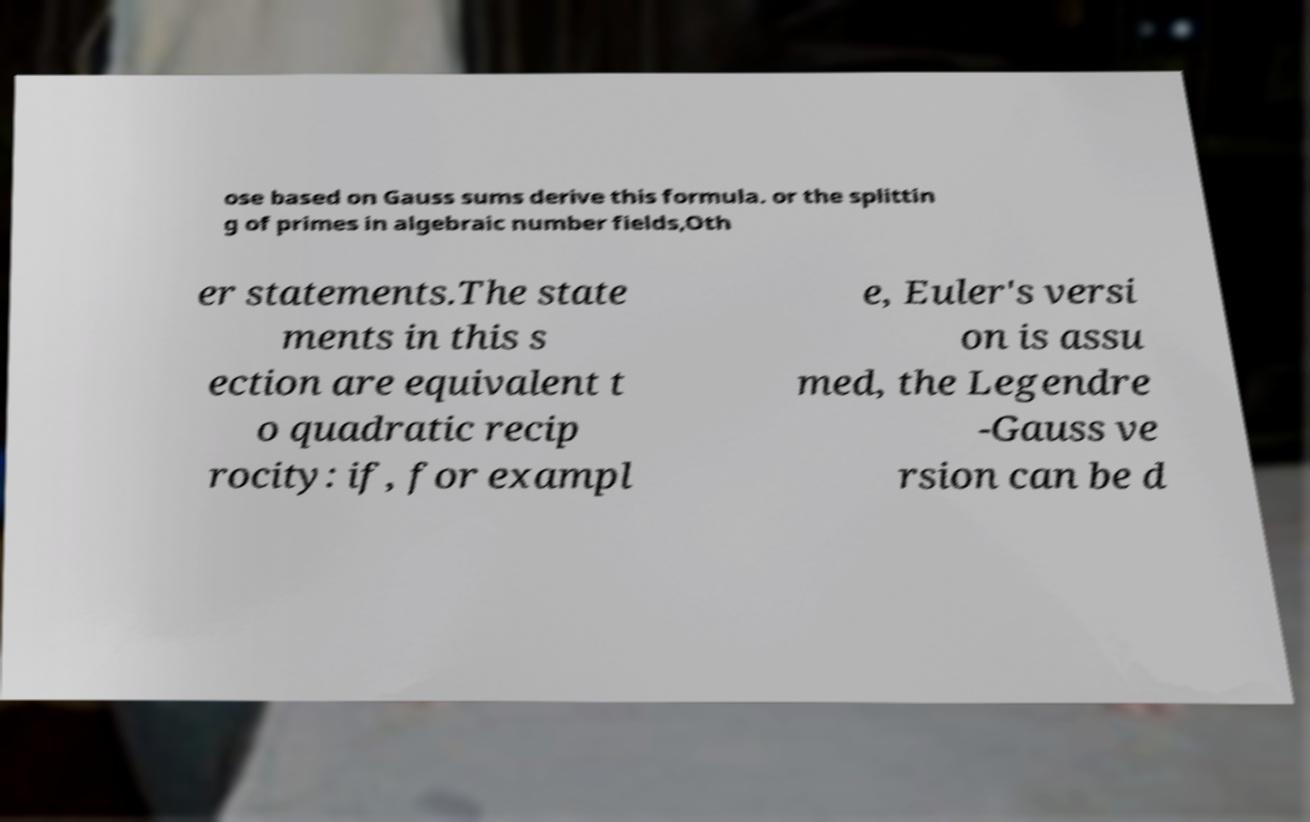Can you read and provide the text displayed in the image?This photo seems to have some interesting text. Can you extract and type it out for me? ose based on Gauss sums derive this formula. or the splittin g of primes in algebraic number fields,Oth er statements.The state ments in this s ection are equivalent t o quadratic recip rocity: if, for exampl e, Euler's versi on is assu med, the Legendre -Gauss ve rsion can be d 